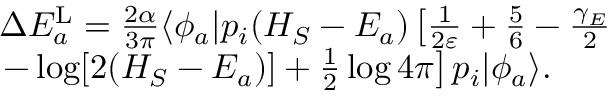<formula> <loc_0><loc_0><loc_500><loc_500>\begin{array} { r l } & { \Delta E _ { a } ^ { L } = \frac { 2 \alpha } { 3 \pi } \langle \phi _ { a } | p _ { i } ( H _ { S } - E _ { a } ) \left [ \frac { 1 } { 2 \varepsilon } + \frac { 5 } { 6 } - \frac { \gamma _ { E } } { 2 } } \\ & { - \log [ 2 ( H _ { S } - E _ { a } ) ] + \frac { 1 } { 2 } \log 4 \pi \right ] p _ { i } | \phi _ { a } \rangle . } \end{array}</formula> 